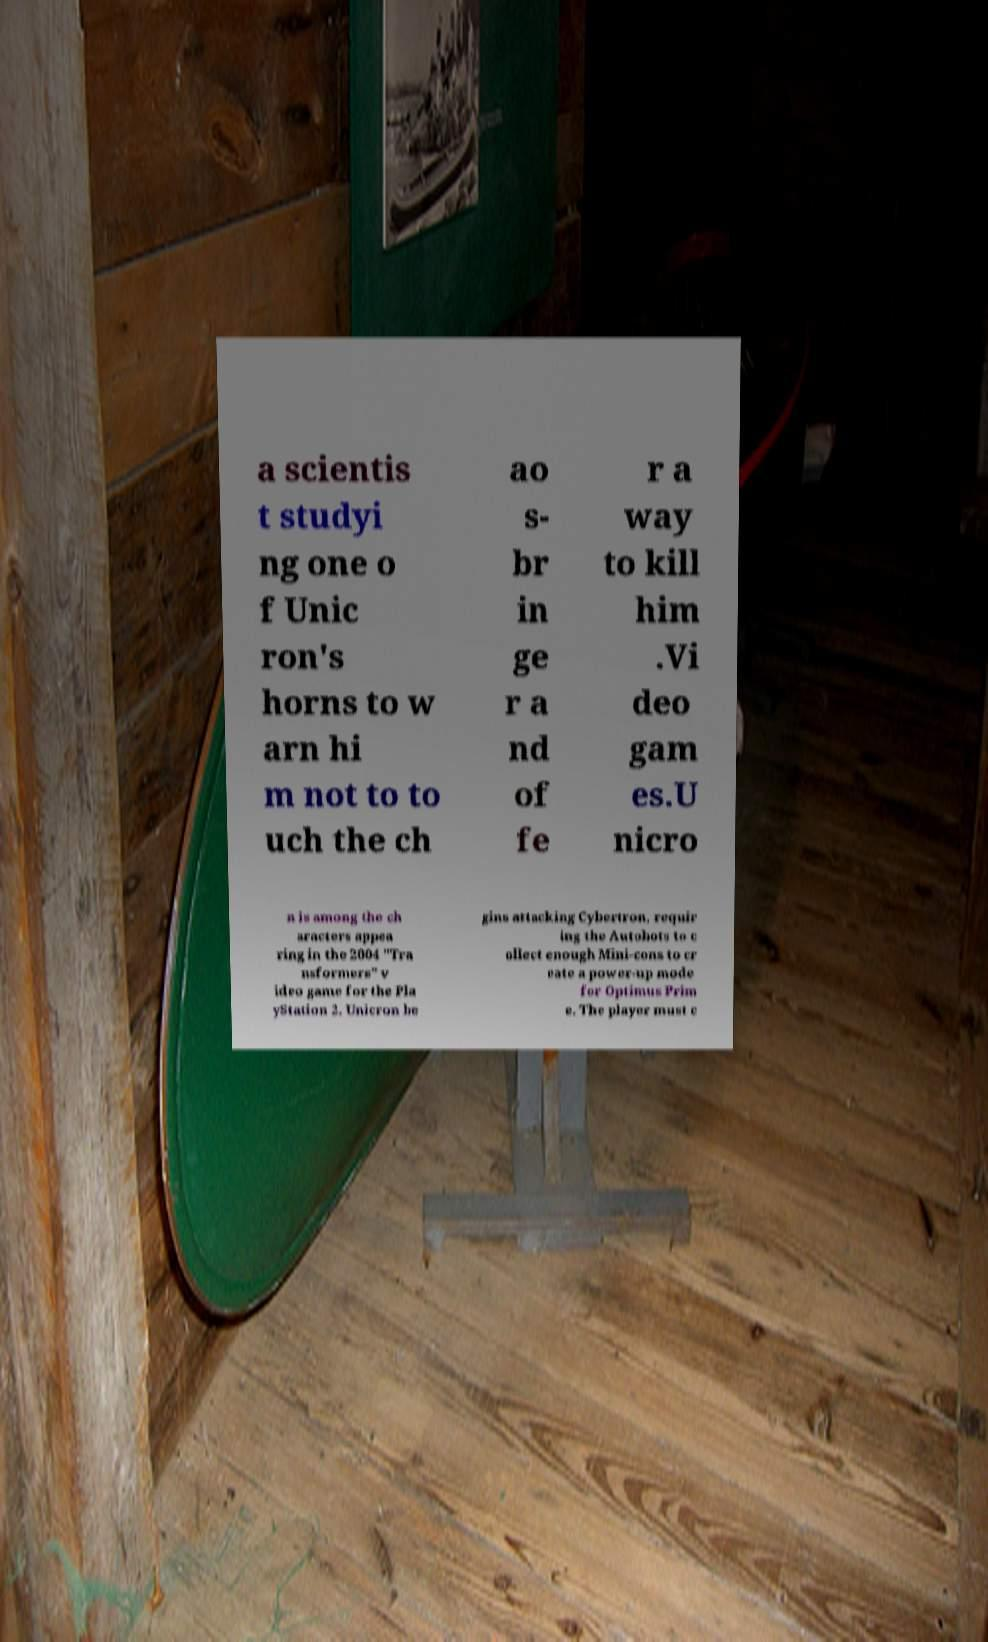For documentation purposes, I need the text within this image transcribed. Could you provide that? a scientis t studyi ng one o f Unic ron's horns to w arn hi m not to to uch the ch ao s- br in ge r a nd of fe r a way to kill him .Vi deo gam es.U nicro n is among the ch aracters appea ring in the 2004 "Tra nsformers" v ideo game for the Pla yStation 2. Unicron be gins attacking Cybertron, requir ing the Autobots to c ollect enough Mini-cons to cr eate a power-up mode for Optimus Prim e. The player must c 